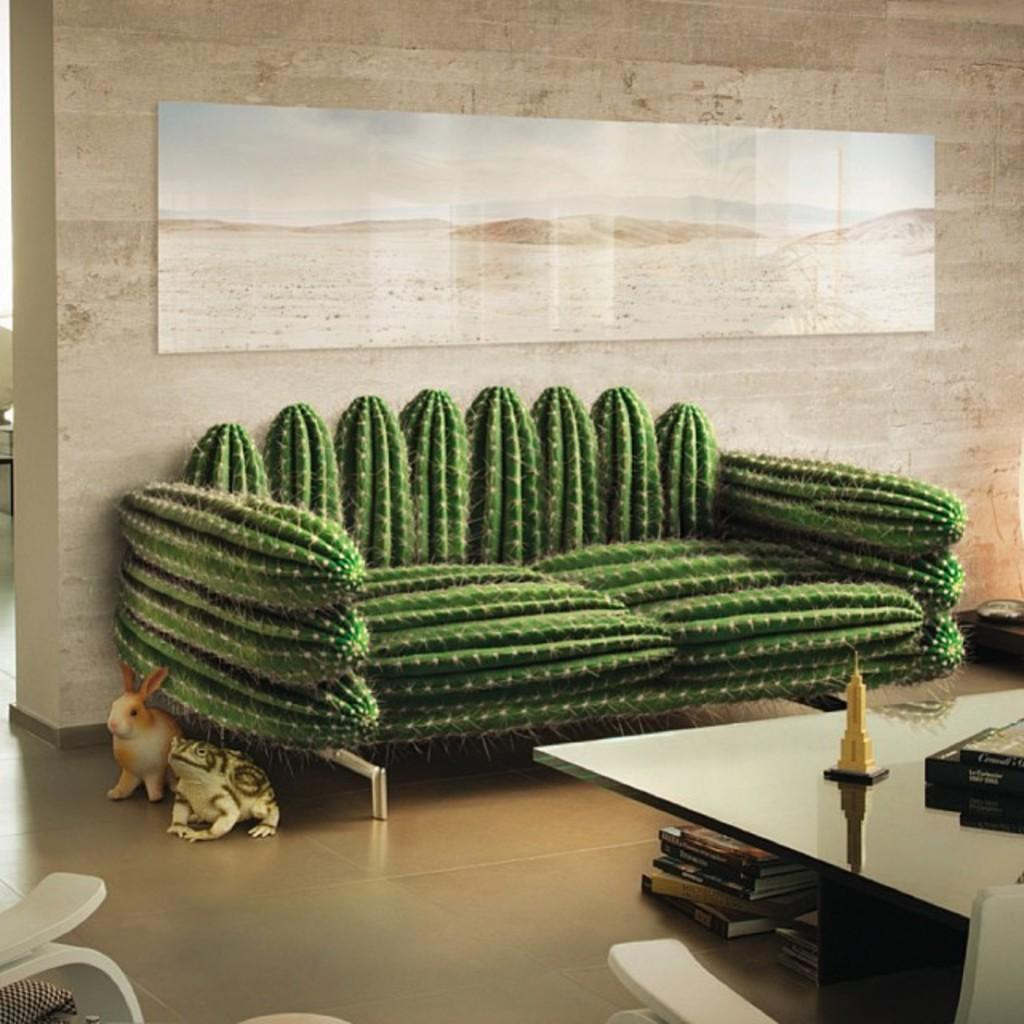What type of furniture is present in the image? There is a sofa set in the image. What type of toy animals can be seen in the image? There is a toy rabbit and a toy frog in the image. What other piece of furniture is visible in the image? There is a table in the image. Where is the mother sitting in the image? There is no mother present in the image. What type of plant is on the table in the image? There is no plant, including a cactus, present on the table in the image. What type of event is taking place in the image? There is no indication of a party or any other event taking place in the image. 